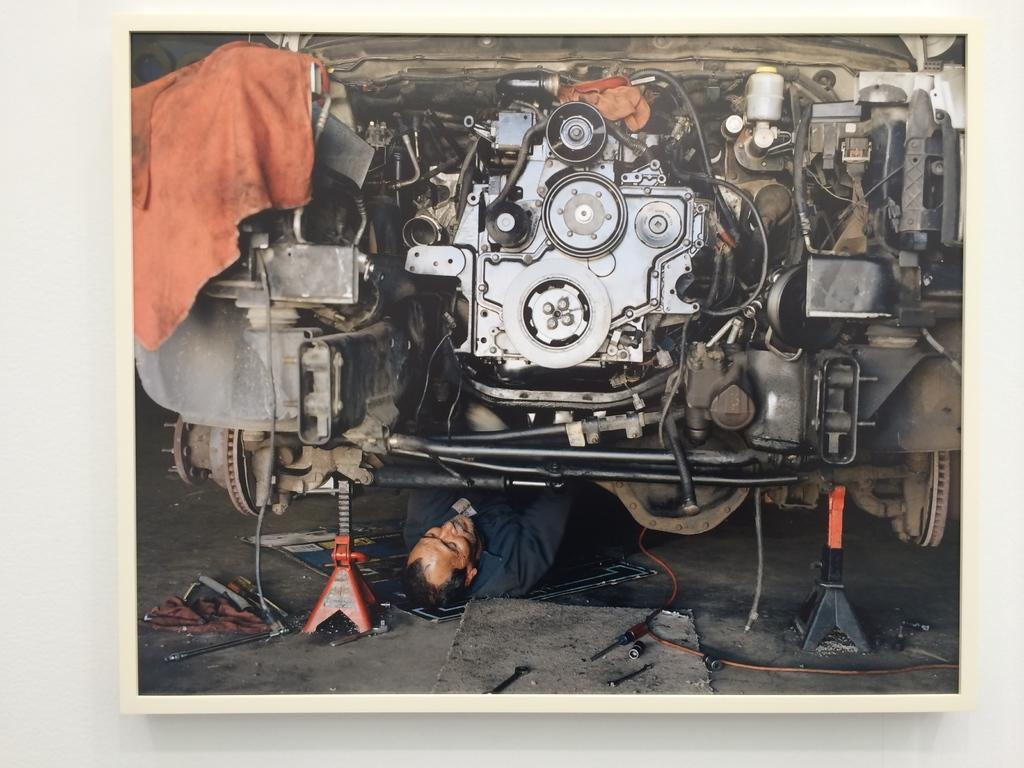What is the position of the man in the image? The man is lying on the ground in the image. What type of equipment can be seen in the image? There are machines in the image. What else is present in the image besides the man and machines? There are wires, clothes, and other objects in the image. What type of tub is visible in the image? There is no tub present in the image. What error can be seen in the image? There is no error visible in the image. 